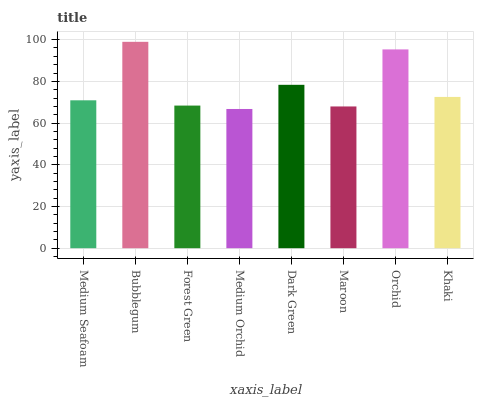Is Forest Green the minimum?
Answer yes or no. No. Is Forest Green the maximum?
Answer yes or no. No. Is Bubblegum greater than Forest Green?
Answer yes or no. Yes. Is Forest Green less than Bubblegum?
Answer yes or no. Yes. Is Forest Green greater than Bubblegum?
Answer yes or no. No. Is Bubblegum less than Forest Green?
Answer yes or no. No. Is Khaki the high median?
Answer yes or no. Yes. Is Medium Seafoam the low median?
Answer yes or no. Yes. Is Dark Green the high median?
Answer yes or no. No. Is Orchid the low median?
Answer yes or no. No. 